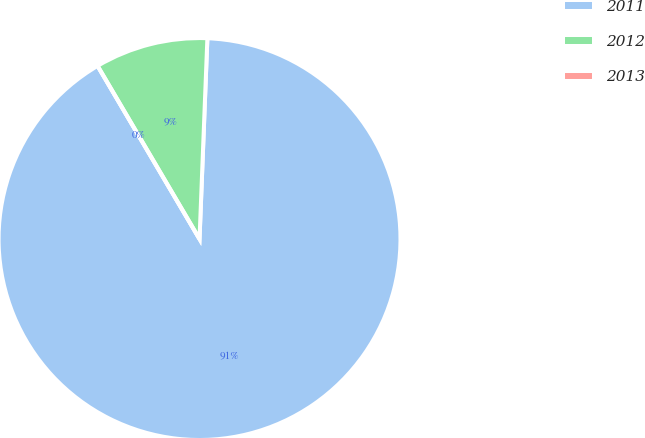Convert chart. <chart><loc_0><loc_0><loc_500><loc_500><pie_chart><fcel>2011<fcel>2012<fcel>2013<nl><fcel>90.91%<fcel>9.09%<fcel>0.0%<nl></chart> 